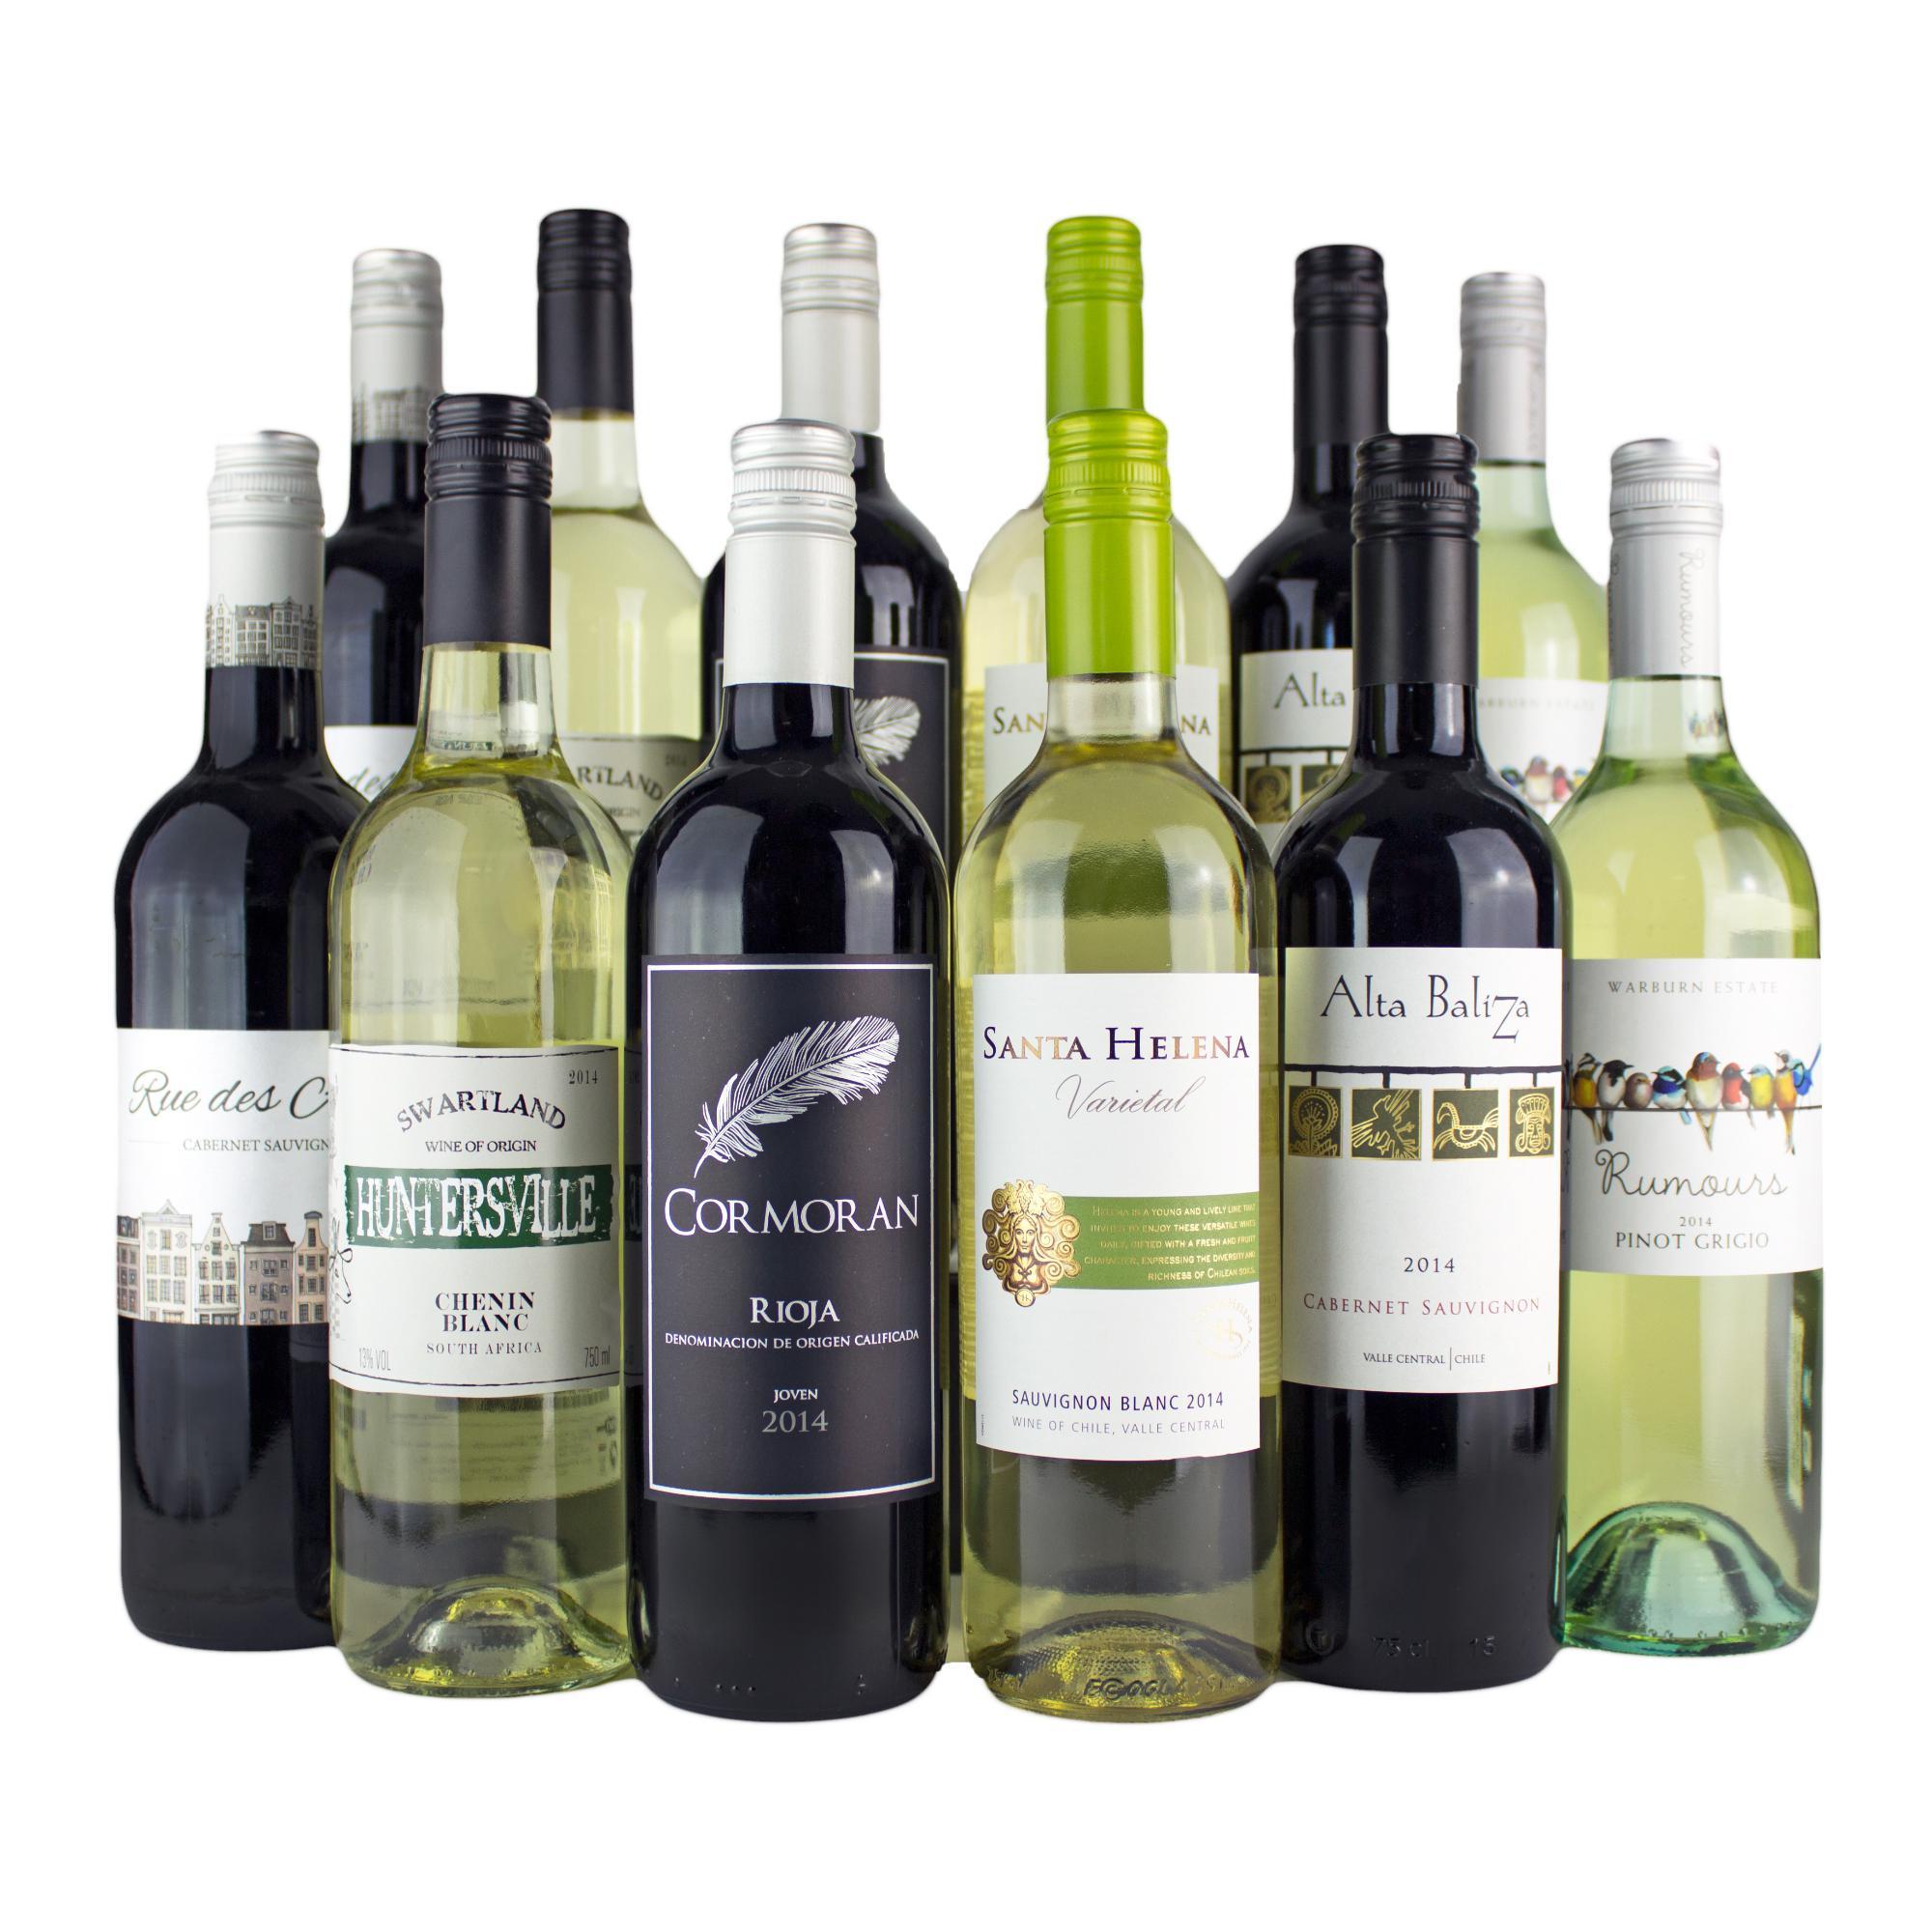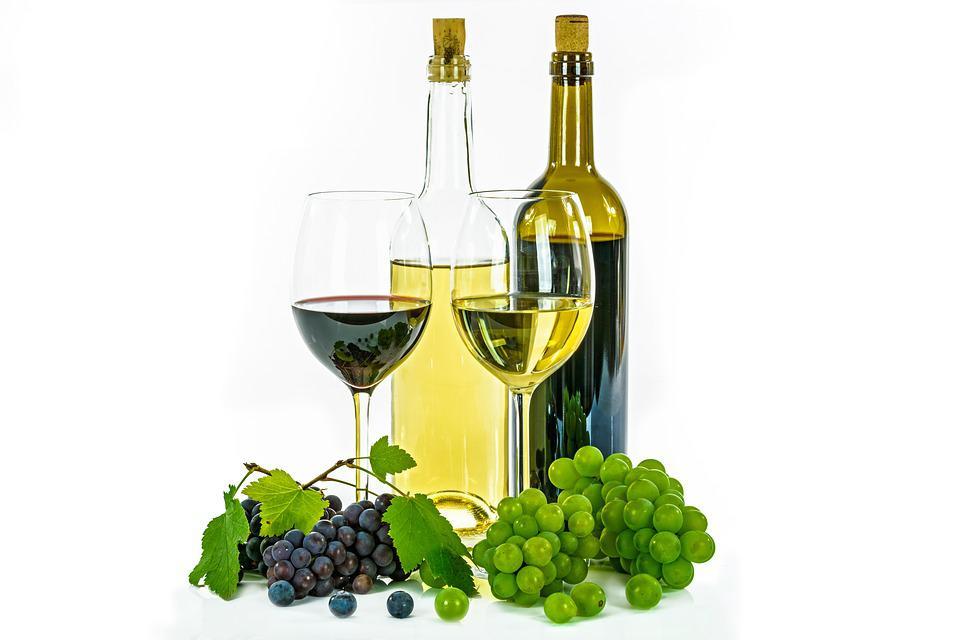The first image is the image on the left, the second image is the image on the right. Analyze the images presented: Is the assertion "Exactly one bottle of wine is standing in one image." valid? Answer yes or no. No. The first image is the image on the left, the second image is the image on the right. For the images shown, is this caption "There is one wine bottle in the left image." true? Answer yes or no. No. 